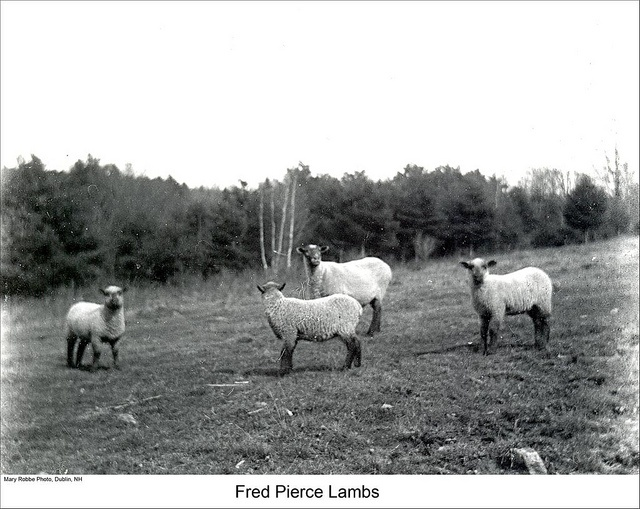Describe the objects in this image and their specific colors. I can see sheep in gray, lightgray, black, and darkgray tones, sheep in gray, darkgray, lightgray, and black tones, sheep in gray, lightgray, darkgray, and black tones, and sheep in gray, black, darkgray, and lightgray tones in this image. 